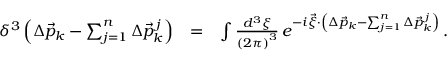<formula> <loc_0><loc_0><loc_500><loc_500>\begin{array} { r l r } { \delta ^ { 3 } \left ( \Delta \vec { p } _ { k } - \sum _ { j = 1 } ^ { n } \Delta \vec { p } _ { k } ^ { \, j } \right ) } & { = } & { \int \frac { d ^ { 3 } \xi } { \left ( 2 \pi \right ) ^ { 3 } } \, e ^ { - i \vec { \xi } \cdot \left ( \Delta \vec { p } _ { k } - \sum _ { j = 1 } ^ { n } \Delta \vec { p } _ { k } ^ { \, j } \right ) } \, . } \end{array}</formula> 